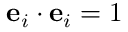<formula> <loc_0><loc_0><loc_500><loc_500>e _ { i } \cdot e _ { i } = 1</formula> 